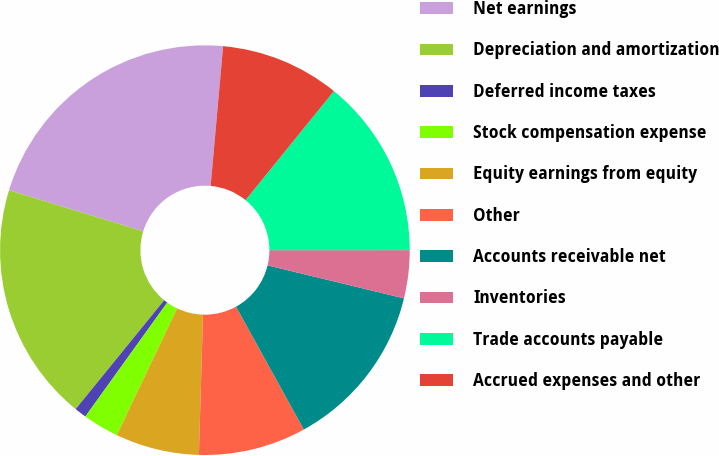Convert chart. <chart><loc_0><loc_0><loc_500><loc_500><pie_chart><fcel>Net earnings<fcel>Depreciation and amortization<fcel>Deferred income taxes<fcel>Stock compensation expense<fcel>Equity earnings from equity<fcel>Other<fcel>Accounts receivable net<fcel>Inventories<fcel>Trade accounts payable<fcel>Accrued expenses and other<nl><fcel>21.69%<fcel>18.86%<fcel>0.95%<fcel>2.84%<fcel>6.61%<fcel>8.49%<fcel>13.2%<fcel>3.78%<fcel>14.15%<fcel>9.43%<nl></chart> 